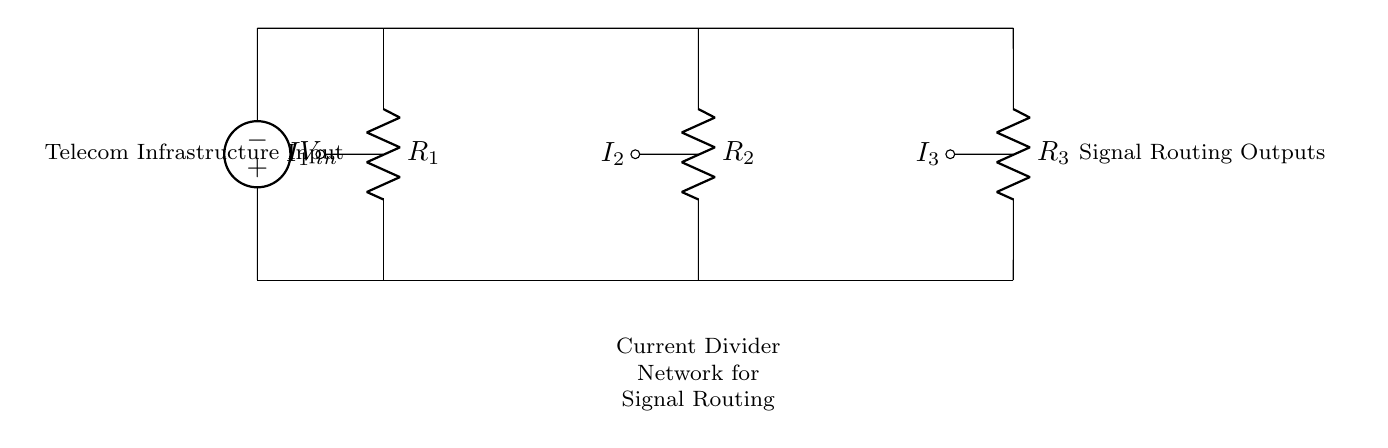What components are in the current divider network? The circuit includes three resistors, R1, R2, and R3, and one voltage source, Vin. These components are essential for the operation of the circuit.
Answer: R1, R2, R3, Vin What is the current flowing through R2? In a current divider, the current through R2 depends on its resistance compared to the total resistance of the circuit. The currents in a current divider can be calculated using the formula I2 = (Vin / (R1 + R2 + R3)) * (R1 + R3), recognizing the ratios of the resistances involved.
Answer: I2 = (Vin / (R1 + R2 + R3)) * (R1 + R3) What role does Vin play in this circuit? Vin is the input voltage source that provides electrical energy to the circuit. It is fundamental as it establishes the potential difference needed to push current through the resistors in the divider.
Answer: Input voltage source How many output branches are in this circuit? The circuit features three branches where the current divides into outputs I1, I2, and I3 corresponding to the three resistors connected in parallel. This structure is typical for current dividers.
Answer: Three Which resistor would have the greatest current flowing through it? The resistor with the lowest resistance value will have the greatest current flowing through it according to Ohm's Law and the current divider rule. Therefore, a comparative analysis of resistances shows which one has the least.
Answer: The one with the lowest resistance What signal output does this network facilitate? The circuit facilitates output signals at I1, I2, and I3, which represent the divided currents for routing signals in telecommunications. Different resistances lead to different current paths and thus are used for specific signal routing.
Answer: Divided currents for routing 